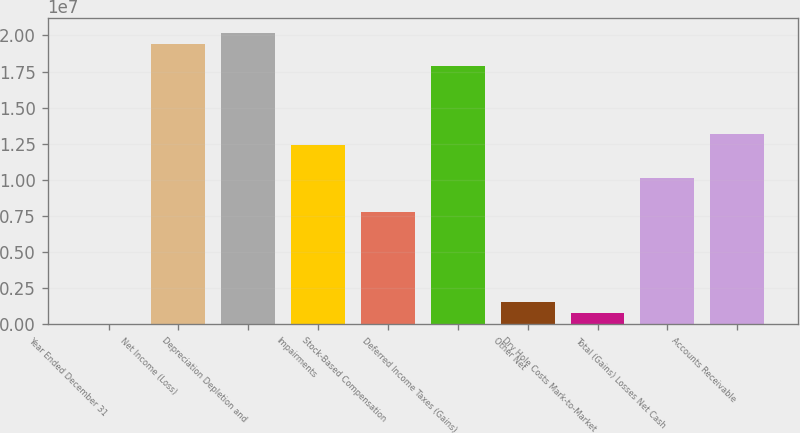Convert chart. <chart><loc_0><loc_0><loc_500><loc_500><bar_chart><fcel>Year Ended December 31<fcel>Net Income (Loss)<fcel>Depreciation Depletion and<fcel>Impairments<fcel>Stock-Based Compensation<fcel>Deferred Income Taxes (Gains)<fcel>Other Net<fcel>Dry Hole Costs Mark-to-Market<fcel>Total (Gains) Losses Net Cash<fcel>Accounts Receivable<nl><fcel>2018<fcel>1.94185e+07<fcel>2.01952e+07<fcel>1.24286e+07<fcel>7.76861e+06<fcel>1.78652e+07<fcel>1.55534e+06<fcel>778677<fcel>1.00986e+07<fcel>1.32052e+07<nl></chart> 